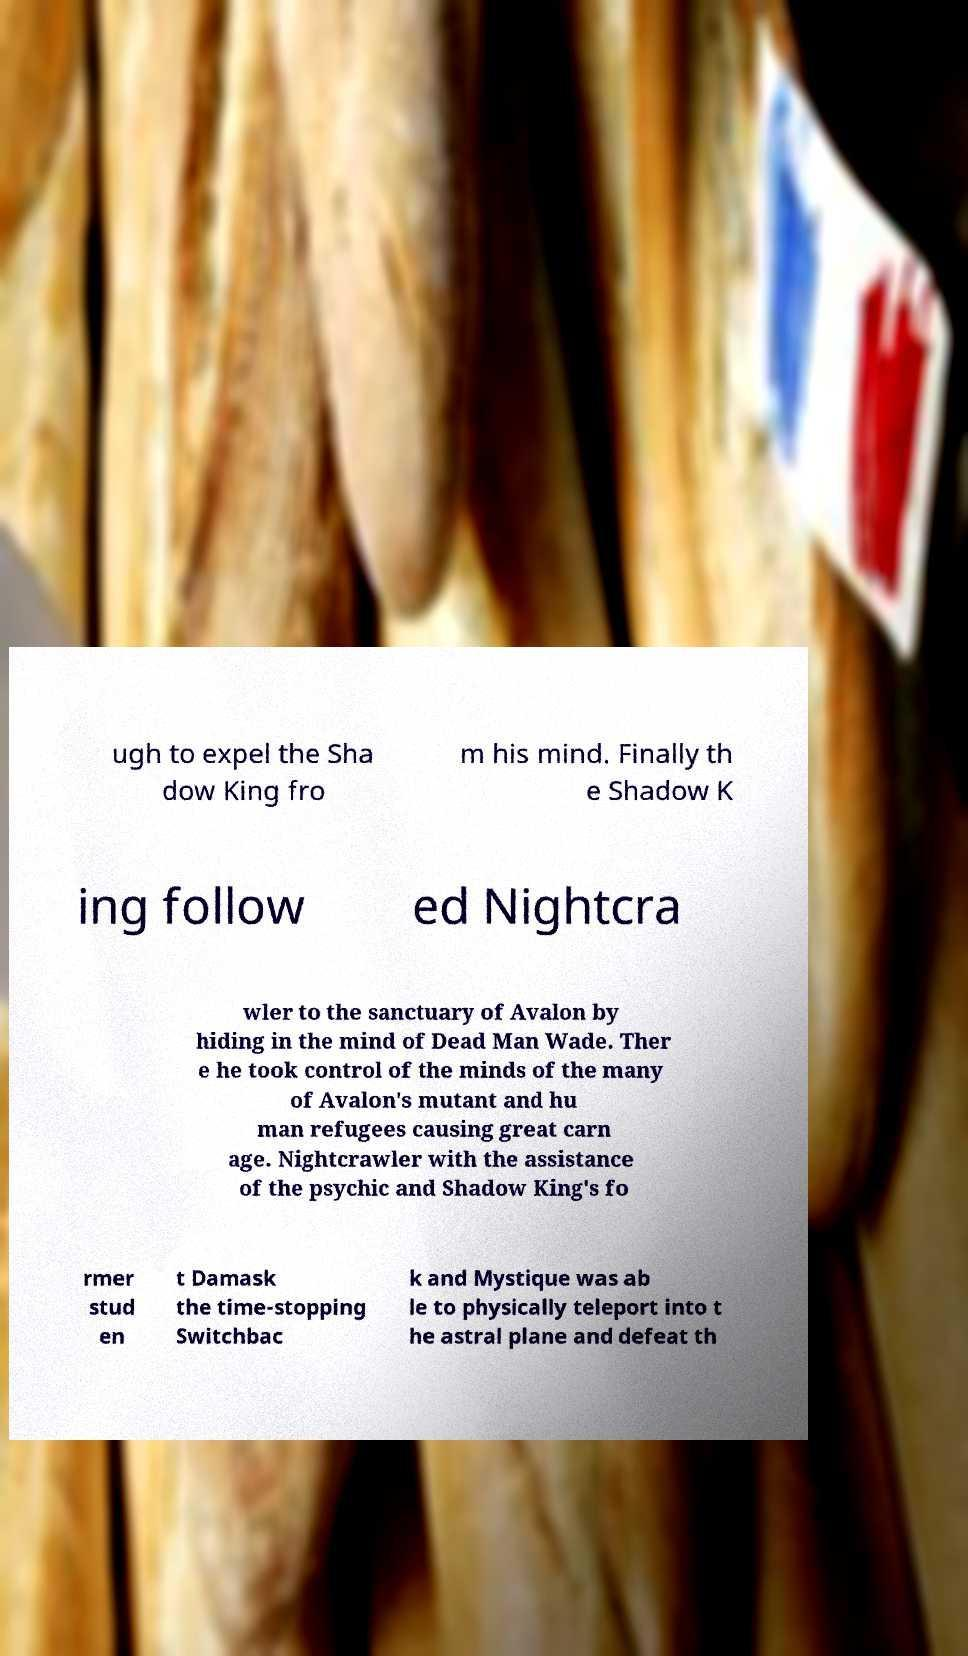For documentation purposes, I need the text within this image transcribed. Could you provide that? ugh to expel the Sha dow King fro m his mind. Finally th e Shadow K ing follow ed Nightcra wler to the sanctuary of Avalon by hiding in the mind of Dead Man Wade. Ther e he took control of the minds of the many of Avalon's mutant and hu man refugees causing great carn age. Nightcrawler with the assistance of the psychic and Shadow King's fo rmer stud en t Damask the time-stopping Switchbac k and Mystique was ab le to physically teleport into t he astral plane and defeat th 